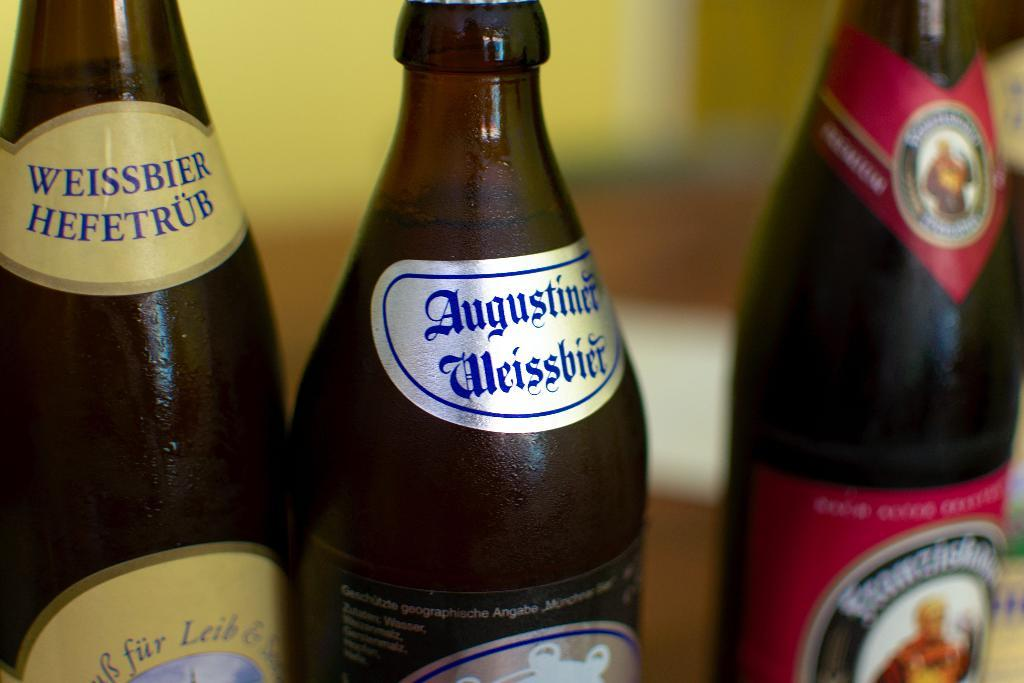<image>
Relay a brief, clear account of the picture shown. bottles of beer like Weissbier Hefetrub lined up together 